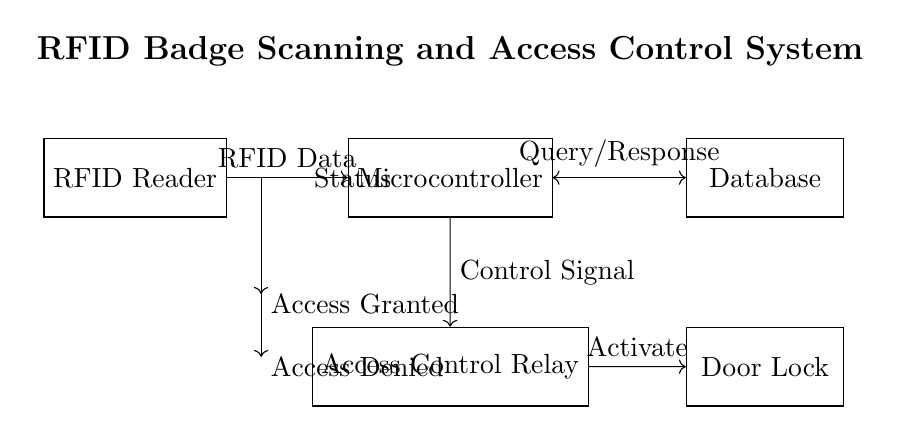What is the primary component that scans the RFID badges? The primary component for scanning RFID badges is the RFID Reader, which is identified at the leftmost position in the circuit diagram. It captures the information encoded in the RFID tags.
Answer: RFID Reader What does the microcontroller do in this circuit? The microcontroller processes the RFID data received from the RFID Reader and interacts with the database to validate access requests. This is evident as it is situated centrally, acting as a hub connecting the reader, database, and access relay.
Answer: Process RFID Data How many LED indicators are present in the diagram? The diagram features two LED indicators: one representing Access Granted and the other for Access Denied, which are clearly labeled beneath the microcontroller connection.
Answer: Two What is the signal direction from the microcontroller to the access control relay? The signal direction is represented with an arrow indicating a Control Signal being sent from the microcontroller to the access control relay. This shows the microcontroller's role in managing access control.
Answer: Control Signal What activates the door lock in this system? The door lock is activated by a control signal sent from the access control relay, as depicted by the directional arrow leading from the relay to the lock, indicating that the relay acts as an intermediary between the microcontroller and the lock.
Answer: Activate Describe the nature of the connection between the microcontroller and the database. The connection between the microcontroller and the database is bidirectional, as shown by the double-headed arrow, allowing for a Query/Response exchange. This means that the microcontroller can both send queries to the database and receive responses back regarding access credentials.
Answer: Query/Response 